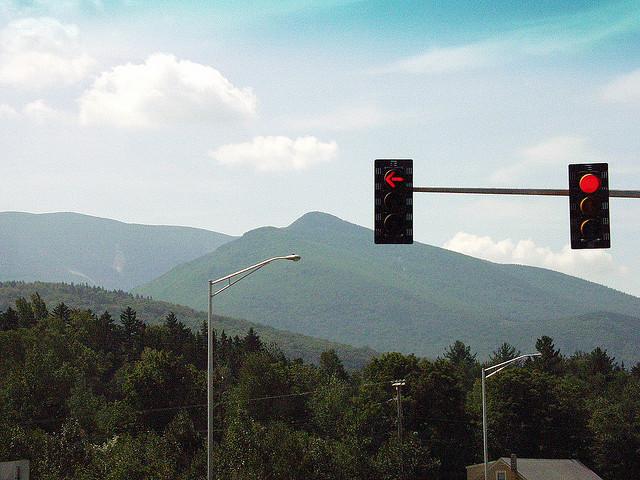What direction is the red arrow pointing?
Answer briefly. Left. What does the red light mean?
Be succinct. Stop. Are the lights the highest above ground thing in the picture?
Keep it brief. No. 